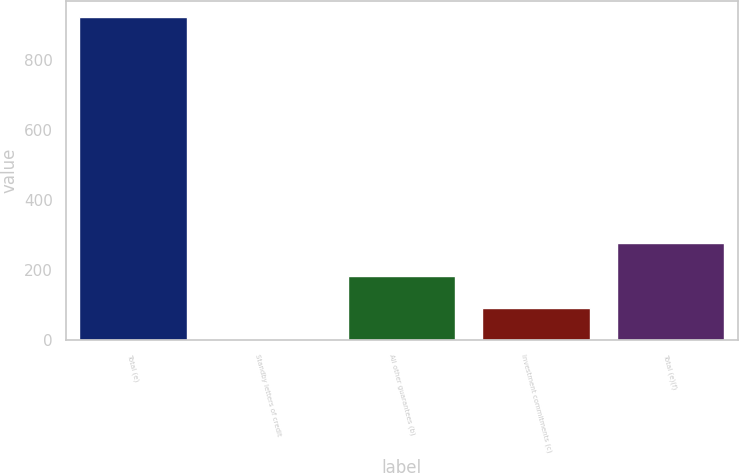<chart> <loc_0><loc_0><loc_500><loc_500><bar_chart><fcel>Total (e)<fcel>Standby letters of credit<fcel>All other guarantees (b)<fcel>Investment commitments (c)<fcel>Total (e)(f)<nl><fcel>923<fcel>1<fcel>185.4<fcel>93.2<fcel>277.6<nl></chart> 